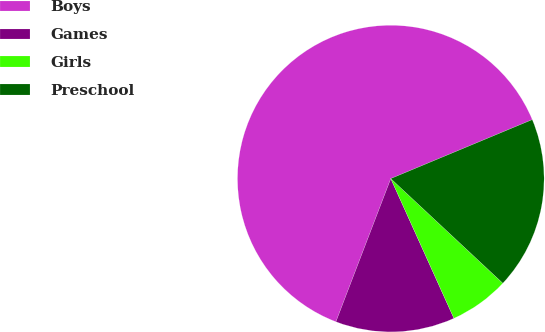Convert chart. <chart><loc_0><loc_0><loc_500><loc_500><pie_chart><fcel>Boys<fcel>Games<fcel>Girls<fcel>Preschool<nl><fcel>62.89%<fcel>12.58%<fcel>6.29%<fcel>18.24%<nl></chart> 